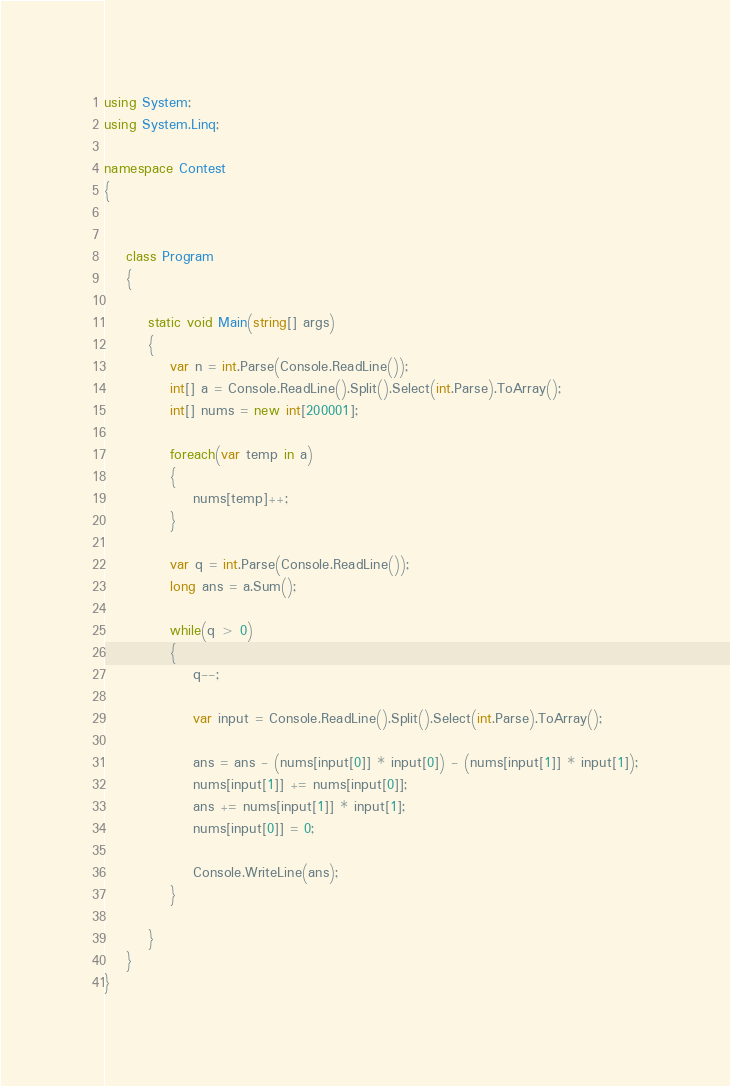Convert code to text. <code><loc_0><loc_0><loc_500><loc_500><_C#_>using System;
using System.Linq;

namespace Contest
{


    class Program
    {

        static void Main(string[] args)
        {
            var n = int.Parse(Console.ReadLine());
            int[] a = Console.ReadLine().Split().Select(int.Parse).ToArray();
            int[] nums = new int[200001];
            
            foreach(var temp in a)
            {
                nums[temp]++;
            }

            var q = int.Parse(Console.ReadLine());
            long ans = a.Sum();

            while(q > 0)
            {
                q--;

                var input = Console.ReadLine().Split().Select(int.Parse).ToArray();

                ans = ans - (nums[input[0]] * input[0]) - (nums[input[1]] * input[1]);
                nums[input[1]] += nums[input[0]];
                ans += nums[input[1]] * input[1];
                nums[input[0]] = 0;

                Console.WriteLine(ans);
            }

        }
    }
}</code> 